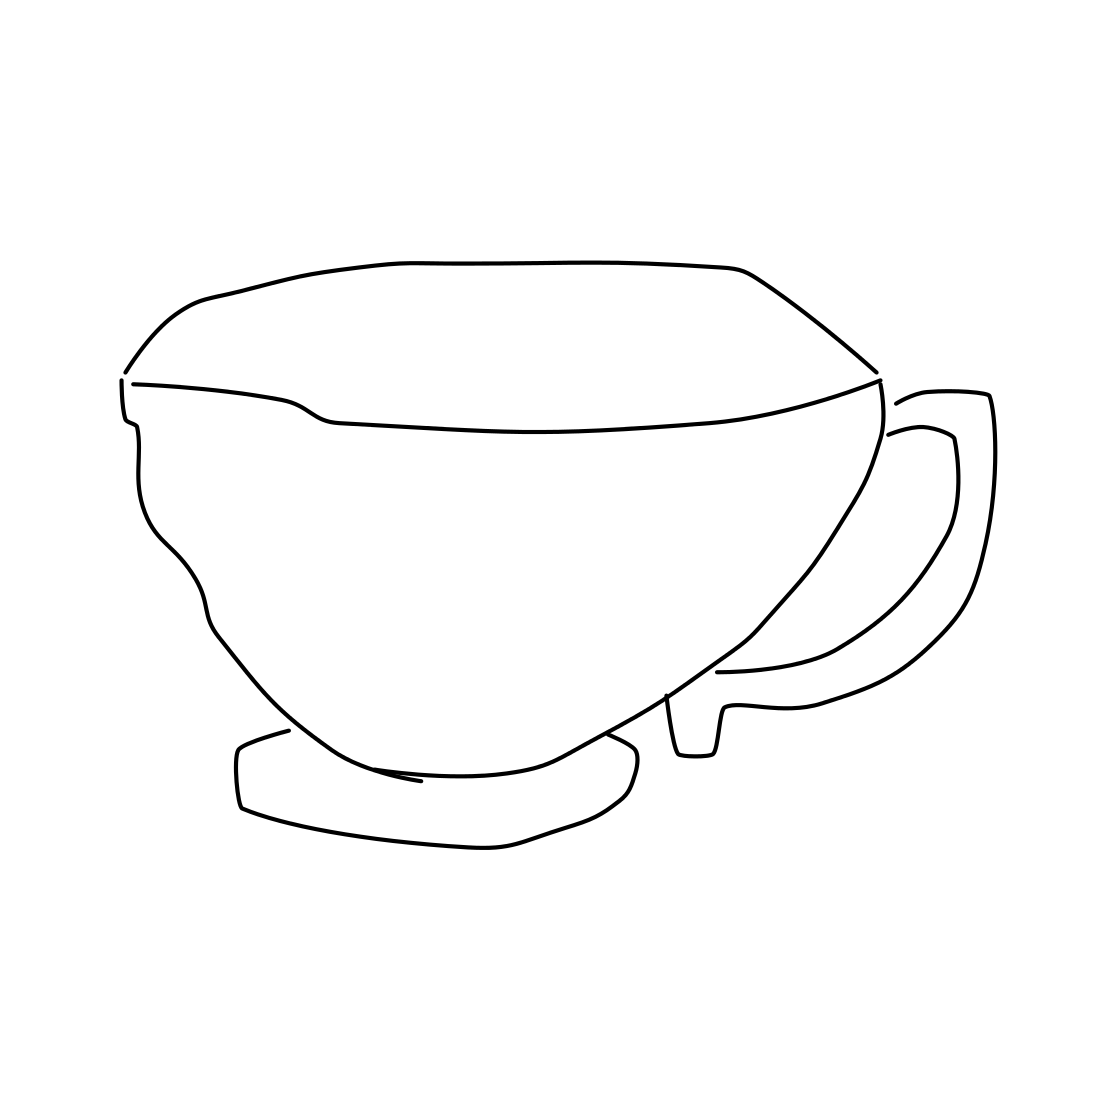What style or culture does the design of this cup represent? The cup presents a minimalist design that is reminiscent of modern Scandinavian style, characterized by simplicity, clean lines, and functionalism. 